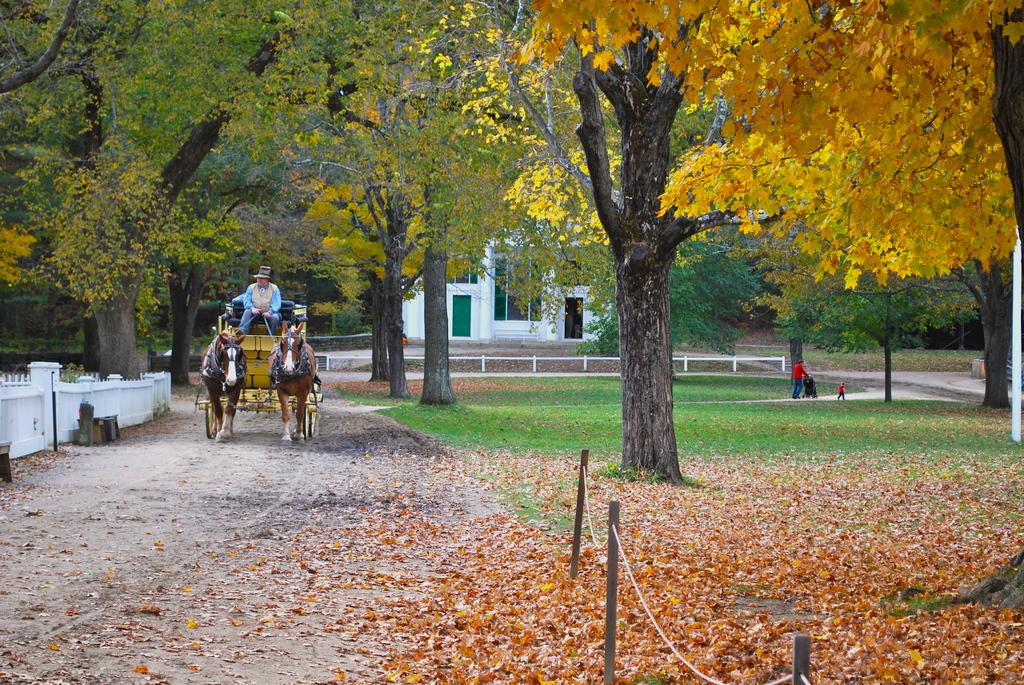What is the person in the image doing? The person is sitting on a horse cart. Who else is present in the image? There is a person holding a baby pram and a child in the image. What can be seen in the background of the image? There are trees, buildings, and poles visible in the image. What is the ground like in the image? The ground is visible in the image. What else is present on the ground? Shredded leaves are present on the ground in the image. How many goats are present in the image? There are no goats present in the image. What color is the horse in the image? There is no horse present in the image; the person is sitting on a horse cart, but the horse itself is not visible. 